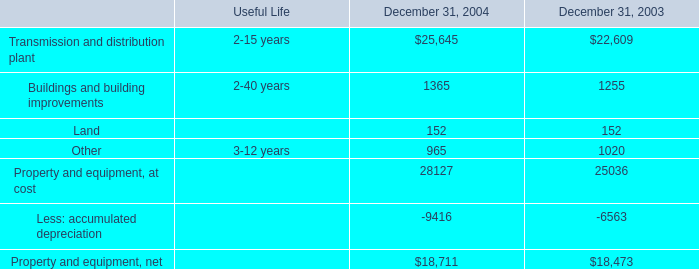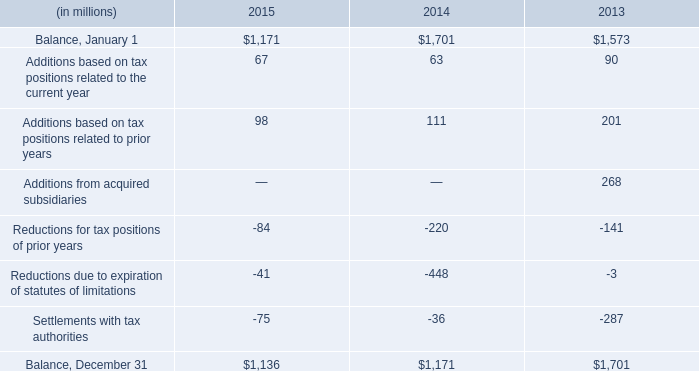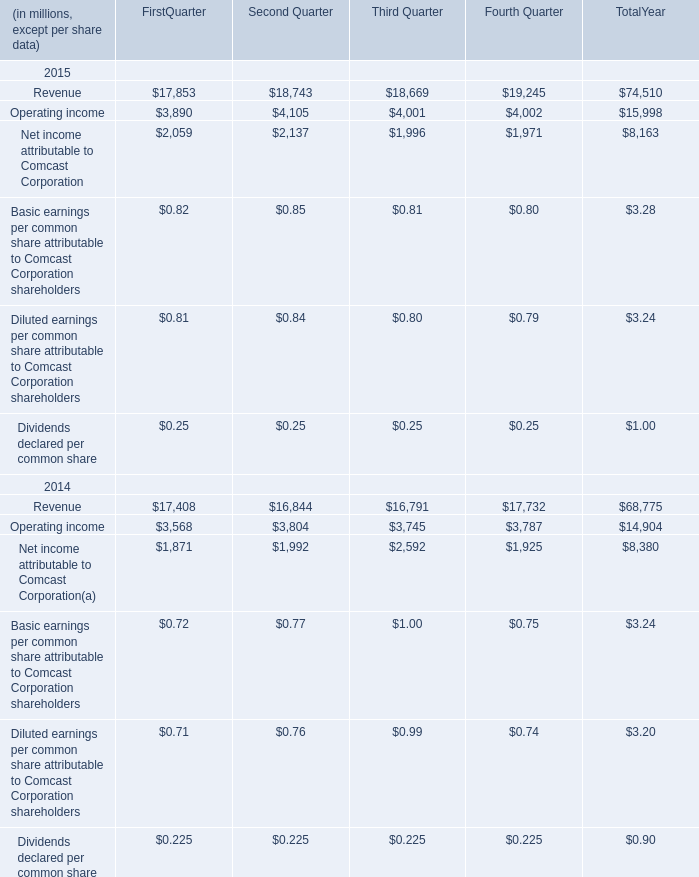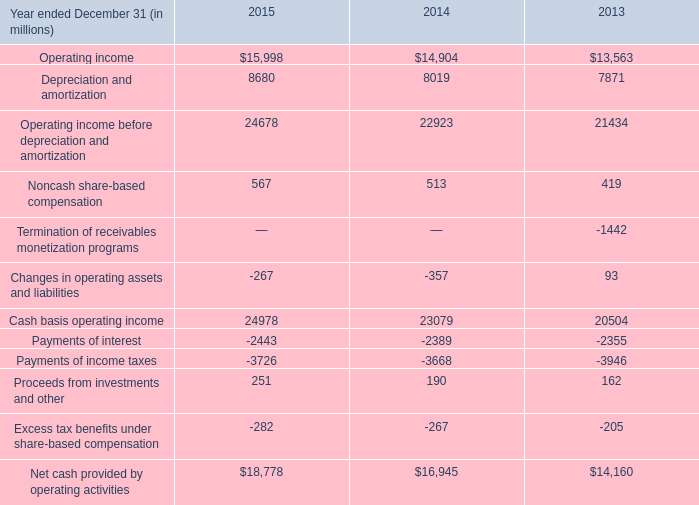in 2015 what was the ratio of the nol carry forward for the federal to the foreign taxes 
Computations: (135 / 700)
Answer: 0.19286. 